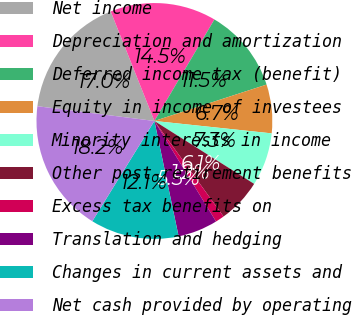Convert chart. <chart><loc_0><loc_0><loc_500><loc_500><pie_chart><fcel>Net income<fcel>Depreciation and amortization<fcel>Deferred income tax (benefit)<fcel>Equity in income of investees<fcel>Minority interests in income<fcel>Other post-retirement benefits<fcel>Excess tax benefits on<fcel>Translation and hedging<fcel>Changes in current assets and<fcel>Net cash provided by operating<nl><fcel>16.96%<fcel>14.54%<fcel>11.51%<fcel>6.67%<fcel>7.28%<fcel>6.07%<fcel>1.22%<fcel>5.46%<fcel>12.12%<fcel>18.17%<nl></chart> 